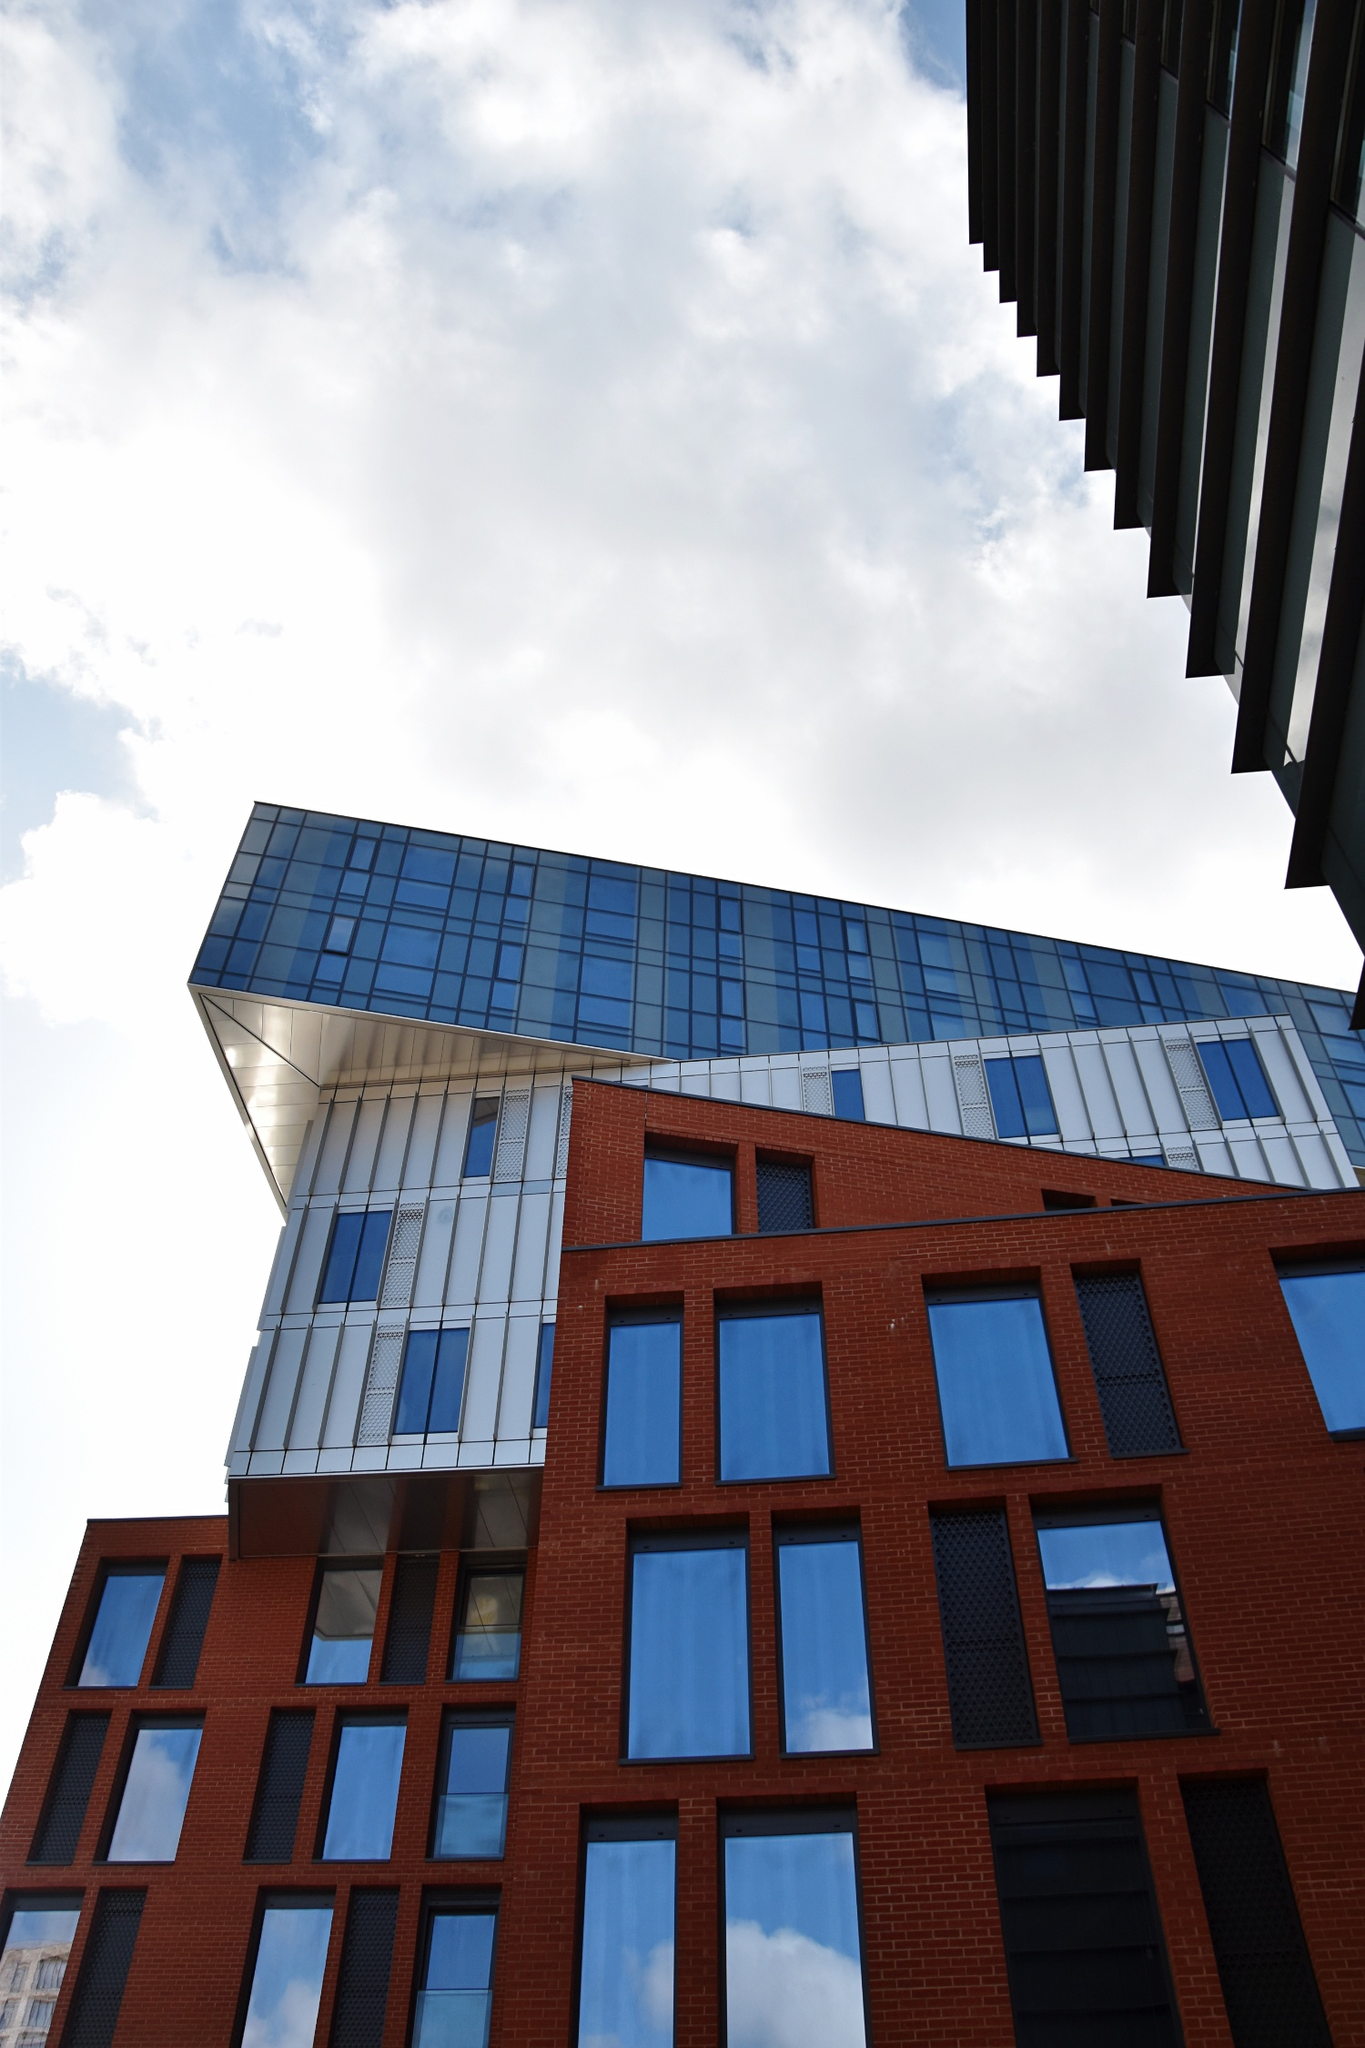What is the building's significance in the local community? The building holds significant importance within the local community as a landmark of modern design and a symbol of progress and innovation. Its unique architectural style attracts visitors and design enthusiasts, making it a point of interest in the city. The ground level possibly hosts retail spaces, cafes, or galleries, creating a vibrant social hub for locals and tourists alike. The building's upper floors might house offices or residential units, contributing to the urban fabric by providing functional space and fostering a sense of community. Overall, this architectural masterpiece represents the community's embrace of contemporary design while respecting historical elements, embodying the spirit of the area’s cultural and socio-economic development. Short version? The building is a local landmark that blends modern design with historical elements, attracting visitors and design enthusiasts. It serves as a social hub with retail spaces and possibly offices or residences, symbolizing the community's progress and innovation. 